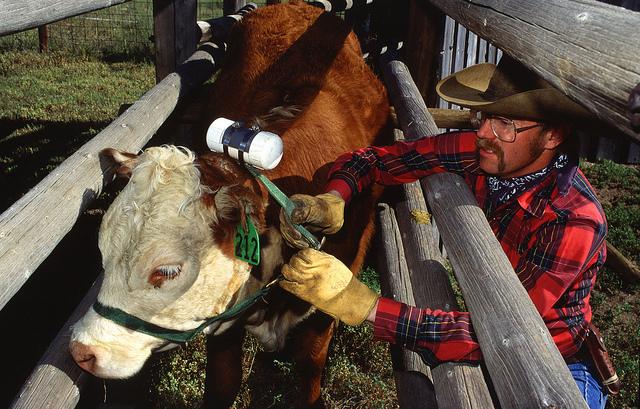What color is the man's bandana?
Quick response, please. Blue. Is the man wearing leather gloves?
Write a very short answer. Yes. What color is the cow's tag?
Write a very short answer. Green. 